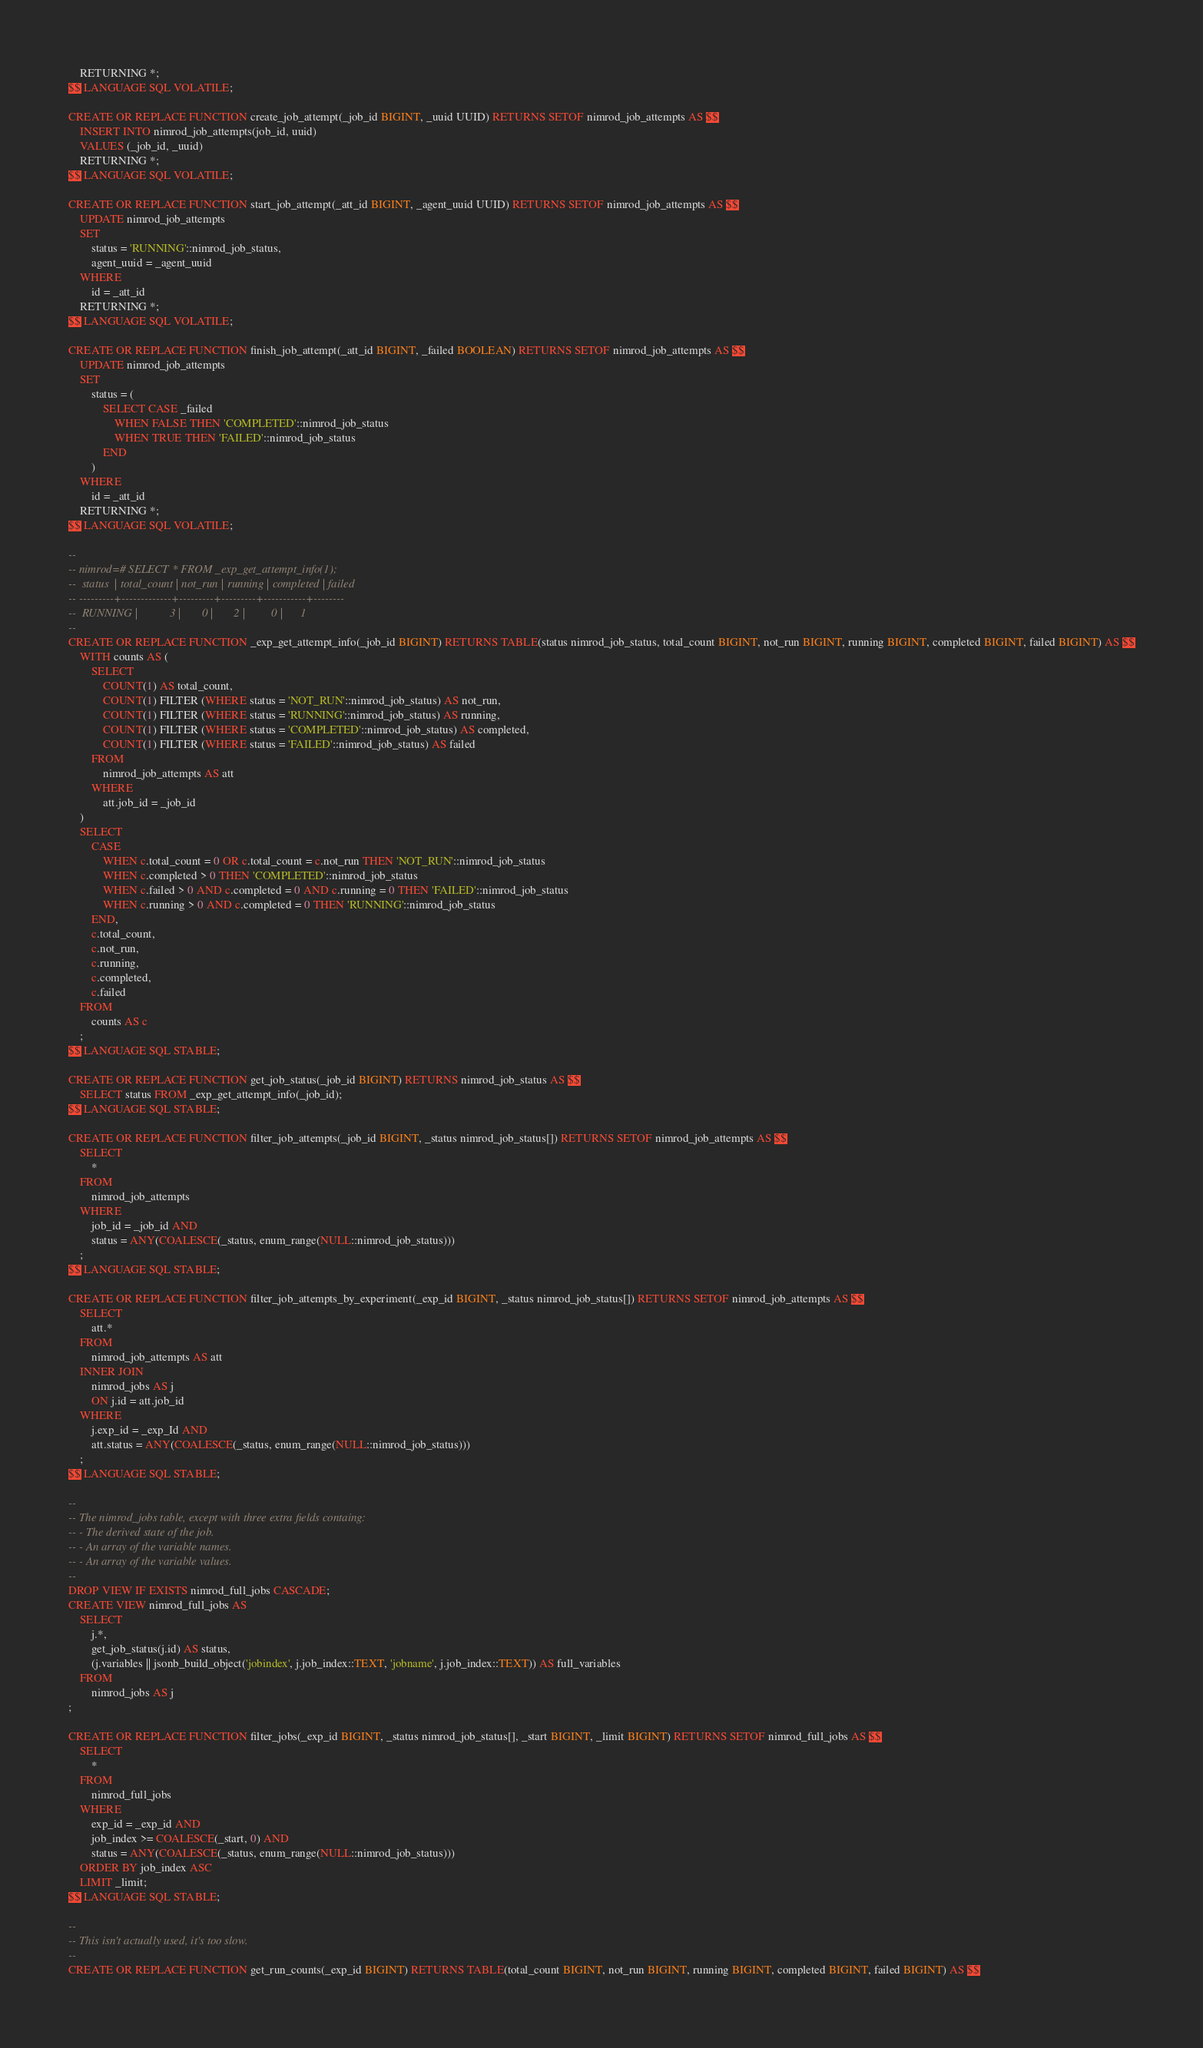Convert code to text. <code><loc_0><loc_0><loc_500><loc_500><_SQL_>    RETURNING *;
$$ LANGUAGE SQL VOLATILE;

CREATE OR REPLACE FUNCTION create_job_attempt(_job_id BIGINT, _uuid UUID) RETURNS SETOF nimrod_job_attempts AS $$
    INSERT INTO nimrod_job_attempts(job_id, uuid)
    VALUES (_job_id, _uuid)
    RETURNING *;
$$ LANGUAGE SQL VOLATILE;

CREATE OR REPLACE FUNCTION start_job_attempt(_att_id BIGINT, _agent_uuid UUID) RETURNS SETOF nimrod_job_attempts AS $$
    UPDATE nimrod_job_attempts
    SET
        status = 'RUNNING'::nimrod_job_status,
        agent_uuid = _agent_uuid
    WHERE
        id = _att_id
    RETURNING *;
$$ LANGUAGE SQL VOLATILE;

CREATE OR REPLACE FUNCTION finish_job_attempt(_att_id BIGINT, _failed BOOLEAN) RETURNS SETOF nimrod_job_attempts AS $$
    UPDATE nimrod_job_attempts
    SET
        status = (
            SELECT CASE _failed
                WHEN FALSE THEN 'COMPLETED'::nimrod_job_status
                WHEN TRUE THEN 'FAILED'::nimrod_job_status
            END
        )
    WHERE
        id = _att_id
    RETURNING *;
$$ LANGUAGE SQL VOLATILE;

--
-- nimrod=# SELECT * FROM _exp_get_attempt_info(1);
--  status  | total_count | not_run | running | completed | failed
-- ---------+-------------+---------+---------+-----------+--------
--  RUNNING |           3 |       0 |       2 |         0 |      1
--
CREATE OR REPLACE FUNCTION _exp_get_attempt_info(_job_id BIGINT) RETURNS TABLE(status nimrod_job_status, total_count BIGINT, not_run BIGINT, running BIGINT, completed BIGINT, failed BIGINT) AS $$
    WITH counts AS (
        SELECT
            COUNT(1) AS total_count,
            COUNT(1) FILTER (WHERE status = 'NOT_RUN'::nimrod_job_status) AS not_run,
            COUNT(1) FILTER (WHERE status = 'RUNNING'::nimrod_job_status) AS running,
            COUNT(1) FILTER (WHERE status = 'COMPLETED'::nimrod_job_status) AS completed,
            COUNT(1) FILTER (WHERE status = 'FAILED'::nimrod_job_status) AS failed
        FROM
            nimrod_job_attempts AS att
        WHERE
            att.job_id = _job_id
    )
    SELECT
        CASE
            WHEN c.total_count = 0 OR c.total_count = c.not_run THEN 'NOT_RUN'::nimrod_job_status
            WHEN c.completed > 0 THEN 'COMPLETED'::nimrod_job_status
            WHEN c.failed > 0 AND c.completed = 0 AND c.running = 0 THEN 'FAILED'::nimrod_job_status
            WHEN c.running > 0 AND c.completed = 0 THEN 'RUNNING'::nimrod_job_status
        END,
        c.total_count,
        c.not_run,
        c.running,
        c.completed,
        c.failed
    FROM
        counts AS c
    ;
$$ LANGUAGE SQL STABLE;

CREATE OR REPLACE FUNCTION get_job_status(_job_id BIGINT) RETURNS nimrod_job_status AS $$
    SELECT status FROM _exp_get_attempt_info(_job_id);
$$ LANGUAGE SQL STABLE;

CREATE OR REPLACE FUNCTION filter_job_attempts(_job_id BIGINT, _status nimrod_job_status[]) RETURNS SETOF nimrod_job_attempts AS $$
    SELECT
        *
    FROM
        nimrod_job_attempts
    WHERE
        job_id = _job_id AND
        status = ANY(COALESCE(_status, enum_range(NULL::nimrod_job_status)))
    ;
$$ LANGUAGE SQL STABLE;

CREATE OR REPLACE FUNCTION filter_job_attempts_by_experiment(_exp_id BIGINT, _status nimrod_job_status[]) RETURNS SETOF nimrod_job_attempts AS $$
    SELECT
        att.*
    FROM
        nimrod_job_attempts AS att
    INNER JOIN
        nimrod_jobs AS j
        ON j.id = att.job_id
    WHERE
        j.exp_id = _exp_Id AND
        att.status = ANY(COALESCE(_status, enum_range(NULL::nimrod_job_status)))
    ;
$$ LANGUAGE SQL STABLE;

--
-- The nimrod_jobs table, except with three extra fields containg:
-- - The derived state of the job.
-- - An array of the variable names.
-- - An array of the variable values.
--
DROP VIEW IF EXISTS nimrod_full_jobs CASCADE;
CREATE VIEW nimrod_full_jobs AS
    SELECT
        j.*,
        get_job_status(j.id) AS status,
        (j.variables || jsonb_build_object('jobindex', j.job_index::TEXT, 'jobname', j.job_index::TEXT)) AS full_variables
    FROM
        nimrod_jobs AS j
;

CREATE OR REPLACE FUNCTION filter_jobs(_exp_id BIGINT, _status nimrod_job_status[], _start BIGINT, _limit BIGINT) RETURNS SETOF nimrod_full_jobs AS $$
    SELECT
        *
    FROM
        nimrod_full_jobs
    WHERE
        exp_id = _exp_id AND
        job_index >= COALESCE(_start, 0) AND
        status = ANY(COALESCE(_status, enum_range(NULL::nimrod_job_status)))
    ORDER BY job_index ASC
    LIMIT _limit;
$$ LANGUAGE SQL STABLE;

--
-- This isn't actually used, it's too slow.
--
CREATE OR REPLACE FUNCTION get_run_counts(_exp_id BIGINT) RETURNS TABLE(total_count BIGINT, not_run BIGINT, running BIGINT, completed BIGINT, failed BIGINT) AS $$</code> 